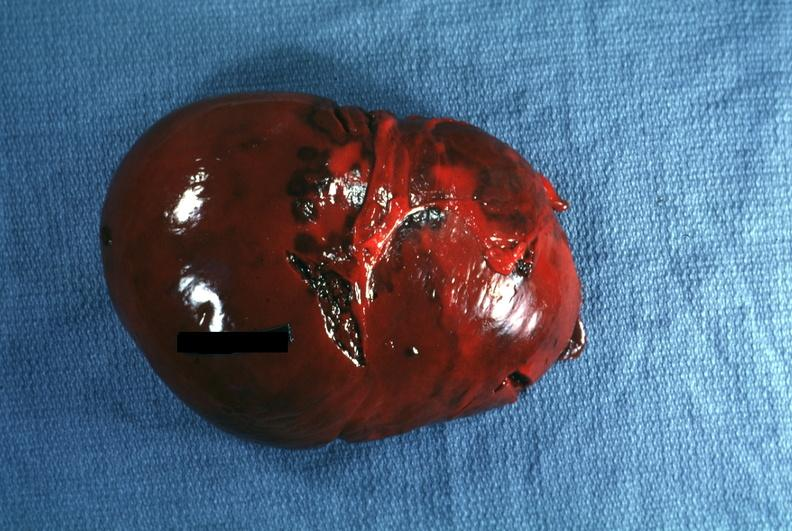s traumatic rupture present?
Answer the question using a single word or phrase. Yes 